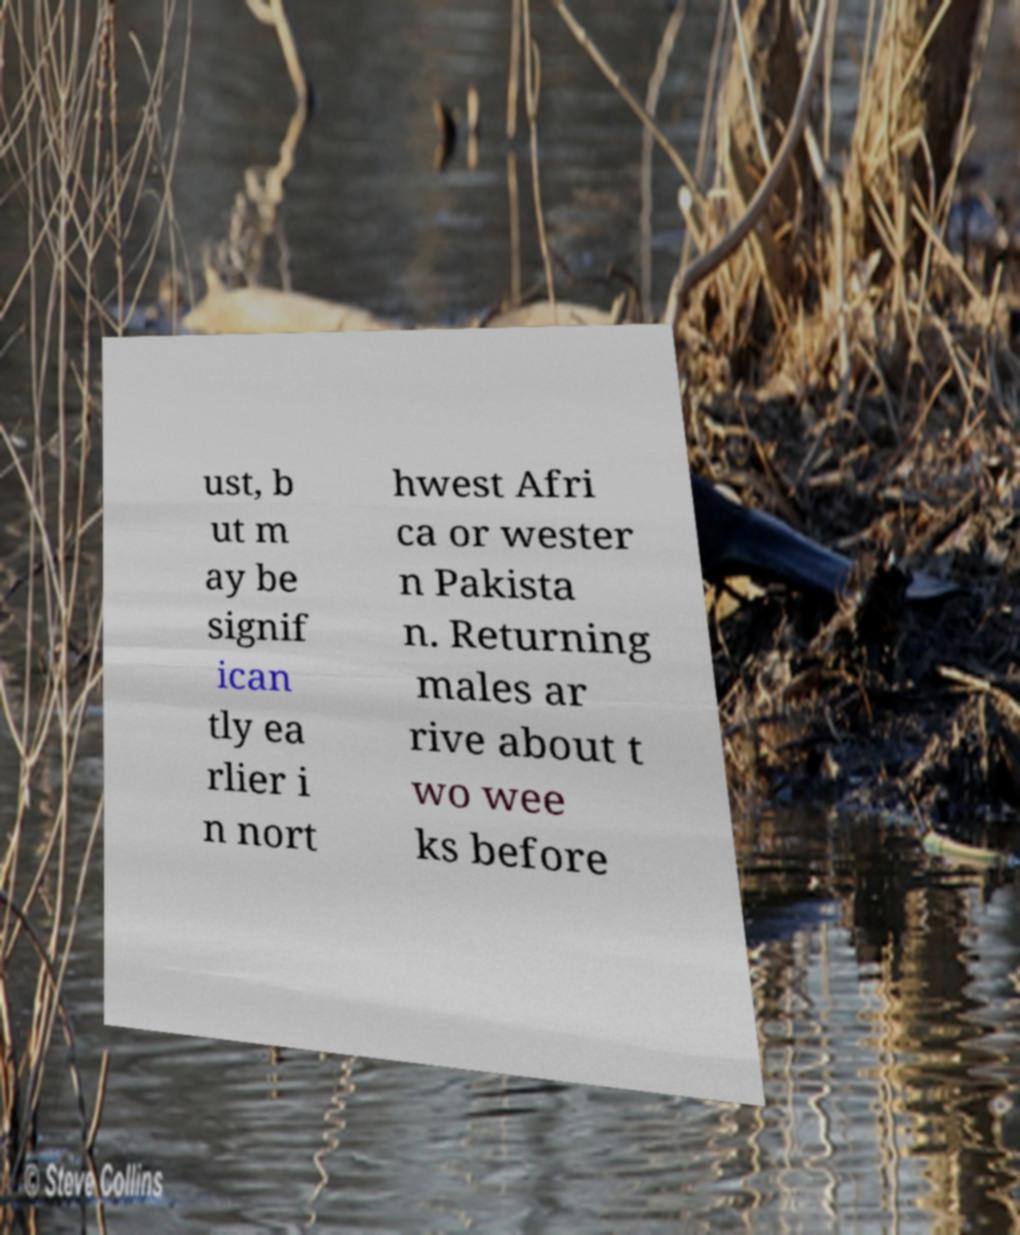Could you extract and type out the text from this image? ust, b ut m ay be signif ican tly ea rlier i n nort hwest Afri ca or wester n Pakista n. Returning males ar rive about t wo wee ks before 